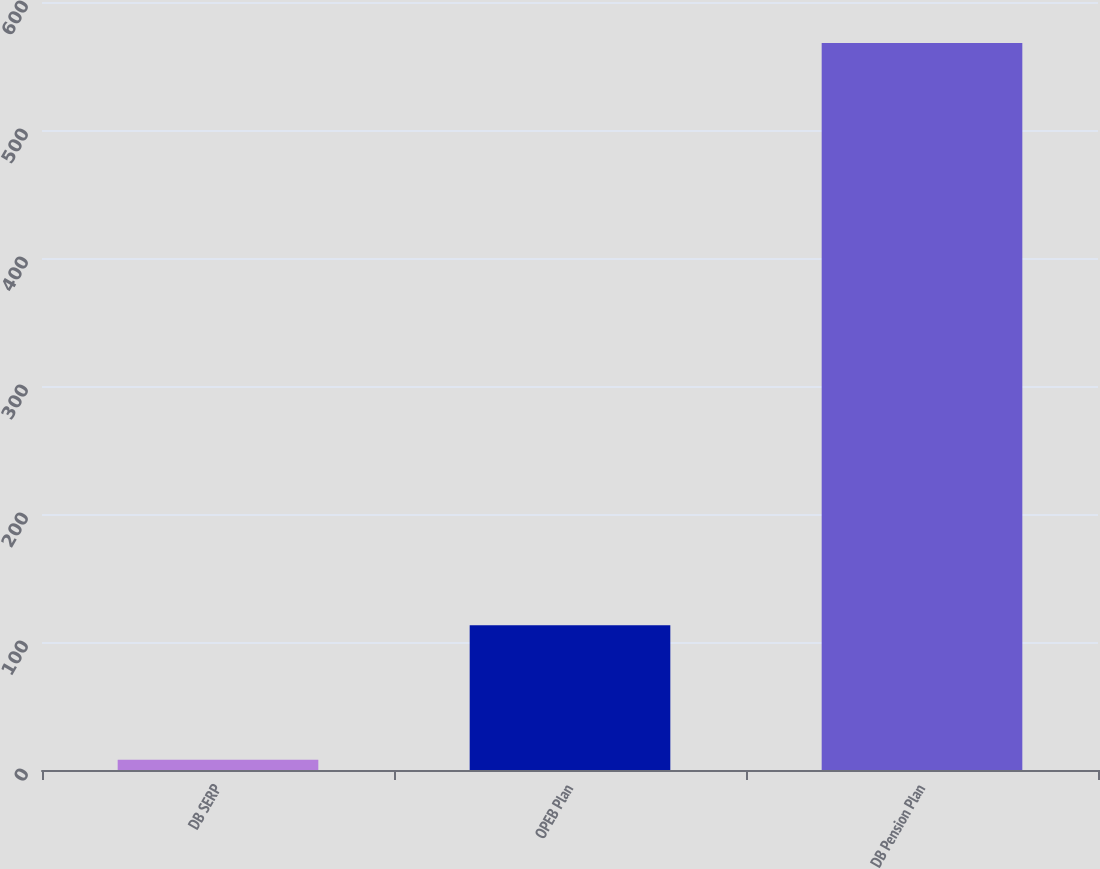Convert chart to OTSL. <chart><loc_0><loc_0><loc_500><loc_500><bar_chart><fcel>DB SERP<fcel>OPEB Plan<fcel>DB Pension Plan<nl><fcel>8<fcel>113<fcel>568<nl></chart> 